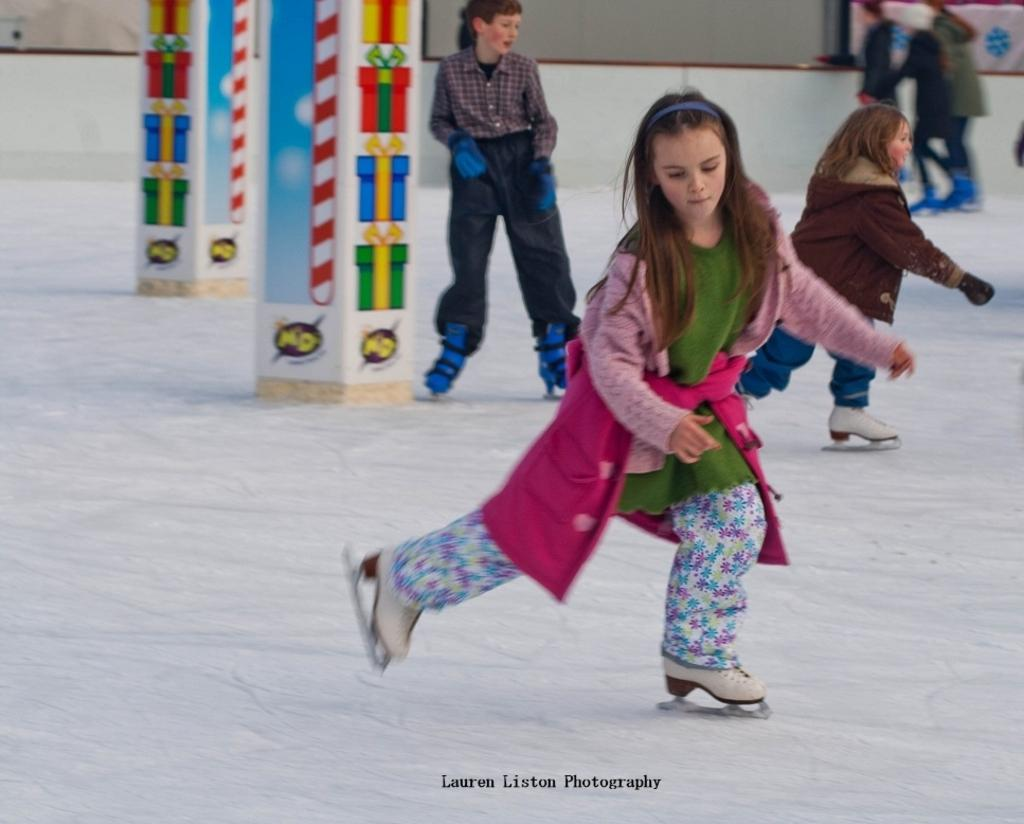Who is present in the image? There are girls in the image. What activity are the girls engaged in? The girls are skating on an ice floor. What type of clothing are the girls wearing? The girls are wearing sweatshirts. What can be seen on the left side of the image? There are pillars on the left side of the image. What type of quiver can be seen on the girls' backs in the image? There is no quiver present on the girls' backs in the image. How many additional girls can be seen in the image, making it a total of five? The number of girls in the image cannot be determined from the provided facts, and there is no mention of a fifth girl. 